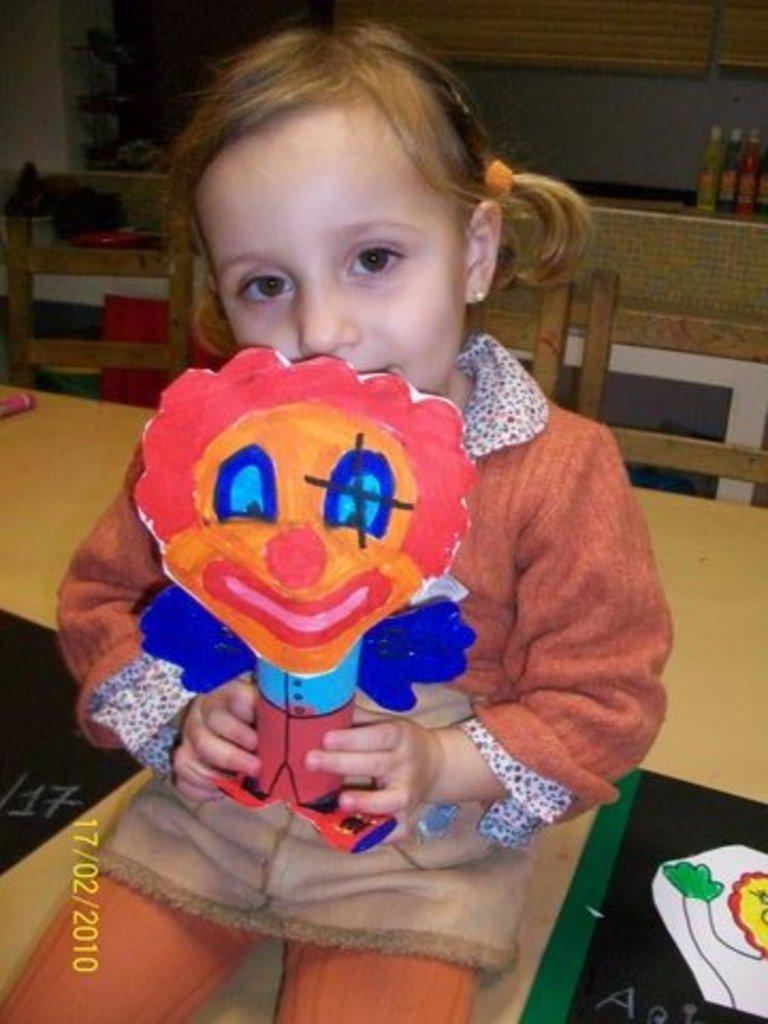Please provide a concise description of this image. In this image, we can see a kid sitting on the chair and holding a toy. In the background, there are chairs and we can see bottles, a table and there are some other objects and we can see some text. 